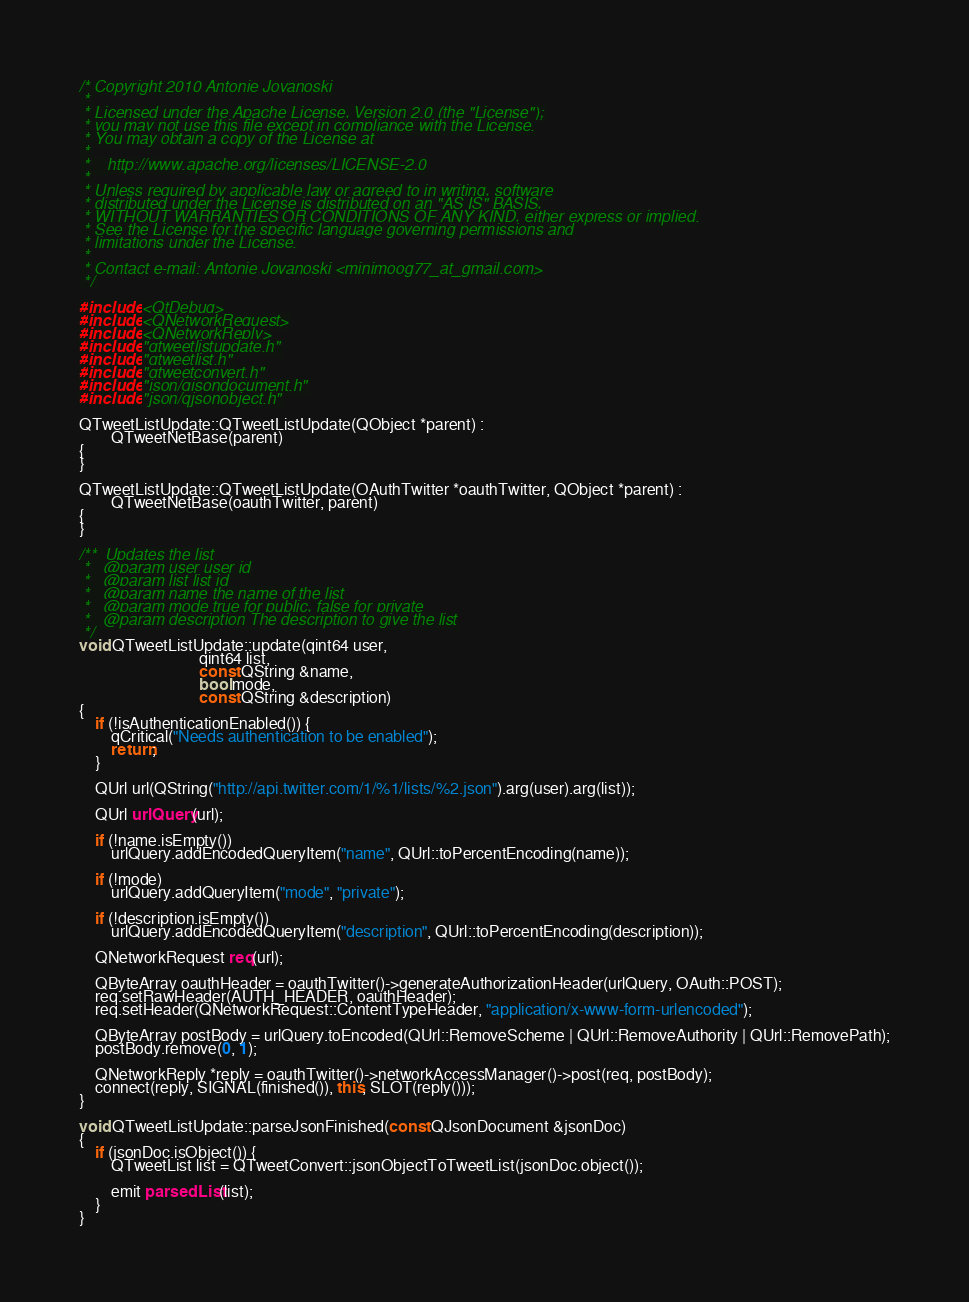<code> <loc_0><loc_0><loc_500><loc_500><_C++_>/* Copyright 2010 Antonie Jovanoski
 *
 * Licensed under the Apache License, Version 2.0 (the "License");
 * you may not use this file except in compliance with the License.
 * You may obtain a copy of the License at
 *
 *    http://www.apache.org/licenses/LICENSE-2.0
 *
 * Unless required by applicable law or agreed to in writing, software
 * distributed under the License is distributed on an "AS IS" BASIS,
 * WITHOUT WARRANTIES OR CONDITIONS OF ANY KIND, either express or implied.
 * See the License for the specific language governing permissions and
 * limitations under the License.
 *
 * Contact e-mail: Antonie Jovanoski <minimoog77_at_gmail.com>
 */

#include <QtDebug>
#include <QNetworkRequest>
#include <QNetworkReply>
#include "qtweetlistupdate.h"
#include "qtweetlist.h"
#include "qtweetconvert.h"
#include "json/qjsondocument.h"
#include "json/qjsonobject.h"

QTweetListUpdate::QTweetListUpdate(QObject *parent) :
        QTweetNetBase(parent)
{
}

QTweetListUpdate::QTweetListUpdate(OAuthTwitter *oauthTwitter, QObject *parent) :
        QTweetNetBase(oauthTwitter, parent)
{
}

/**  Updates the list
 *   @param user user id
 *   @param list list id
 *   @param name the name of the list
 *   @param mode true for public, false for private
 *   @param description The description to give the list
 */
void QTweetListUpdate::update(qint64 user,
                              qint64 list,
                              const QString &name,
                              bool mode,
                              const QString &description)
{
    if (!isAuthenticationEnabled()) {
        qCritical("Needs authentication to be enabled");
        return;
    }

    QUrl url(QString("http://api.twitter.com/1/%1/lists/%2.json").arg(user).arg(list));

    QUrl urlQuery(url);

    if (!name.isEmpty())
        urlQuery.addEncodedQueryItem("name", QUrl::toPercentEncoding(name));

    if (!mode)
        urlQuery.addQueryItem("mode", "private");

    if (!description.isEmpty())
        urlQuery.addEncodedQueryItem("description", QUrl::toPercentEncoding(description));

    QNetworkRequest req(url);

    QByteArray oauthHeader = oauthTwitter()->generateAuthorizationHeader(urlQuery, OAuth::POST);
    req.setRawHeader(AUTH_HEADER, oauthHeader);
    req.setHeader(QNetworkRequest::ContentTypeHeader, "application/x-www-form-urlencoded");

    QByteArray postBody = urlQuery.toEncoded(QUrl::RemoveScheme | QUrl::RemoveAuthority | QUrl::RemovePath);
    postBody.remove(0, 1);

    QNetworkReply *reply = oauthTwitter()->networkAccessManager()->post(req, postBody);
    connect(reply, SIGNAL(finished()), this, SLOT(reply()));
}

void QTweetListUpdate::parseJsonFinished(const QJsonDocument &jsonDoc)
{
    if (jsonDoc.isObject()) {
        QTweetList list = QTweetConvert::jsonObjectToTweetList(jsonDoc.object());

        emit parsedList(list);
    }
}
</code> 